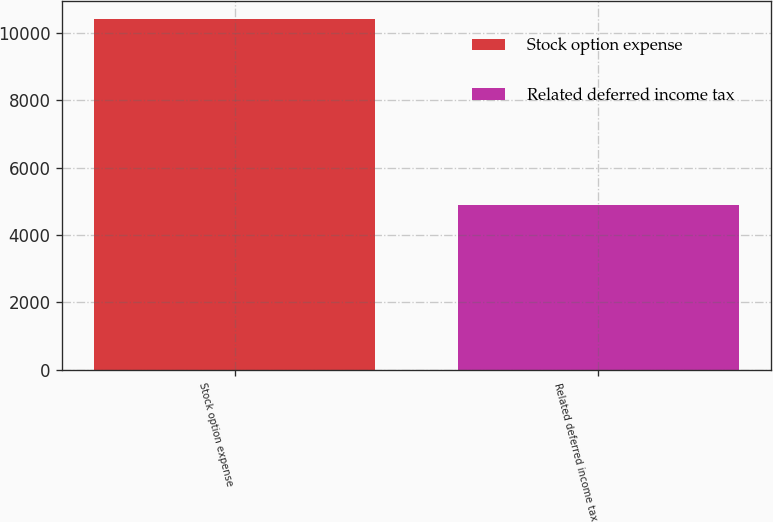Convert chart to OTSL. <chart><loc_0><loc_0><loc_500><loc_500><bar_chart><fcel>Stock option expense<fcel>Related deferred income tax<nl><fcel>10420<fcel>4886<nl></chart> 